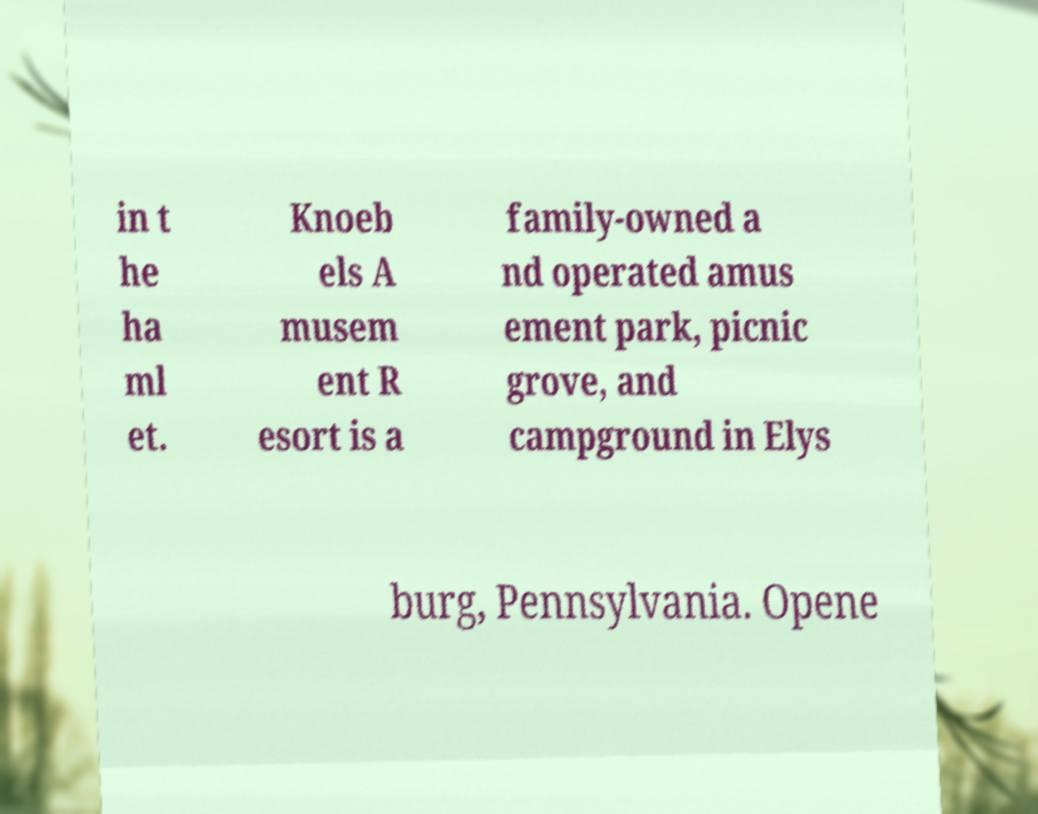There's text embedded in this image that I need extracted. Can you transcribe it verbatim? in t he ha ml et. Knoeb els A musem ent R esort is a family-owned a nd operated amus ement park, picnic grove, and campground in Elys burg, Pennsylvania. Opene 